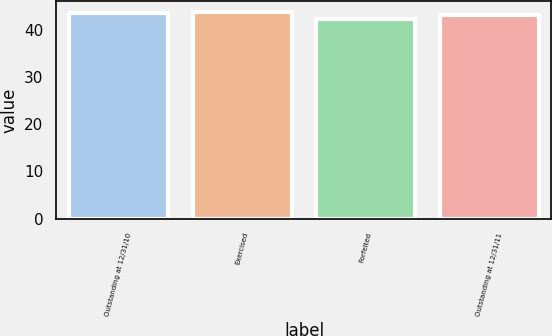Convert chart. <chart><loc_0><loc_0><loc_500><loc_500><bar_chart><fcel>Outstanding at 12/31/10<fcel>Exercised<fcel>Forfeited<fcel>Outstanding at 12/31/11<nl><fcel>43.59<fcel>43.84<fcel>42.25<fcel>43.05<nl></chart> 